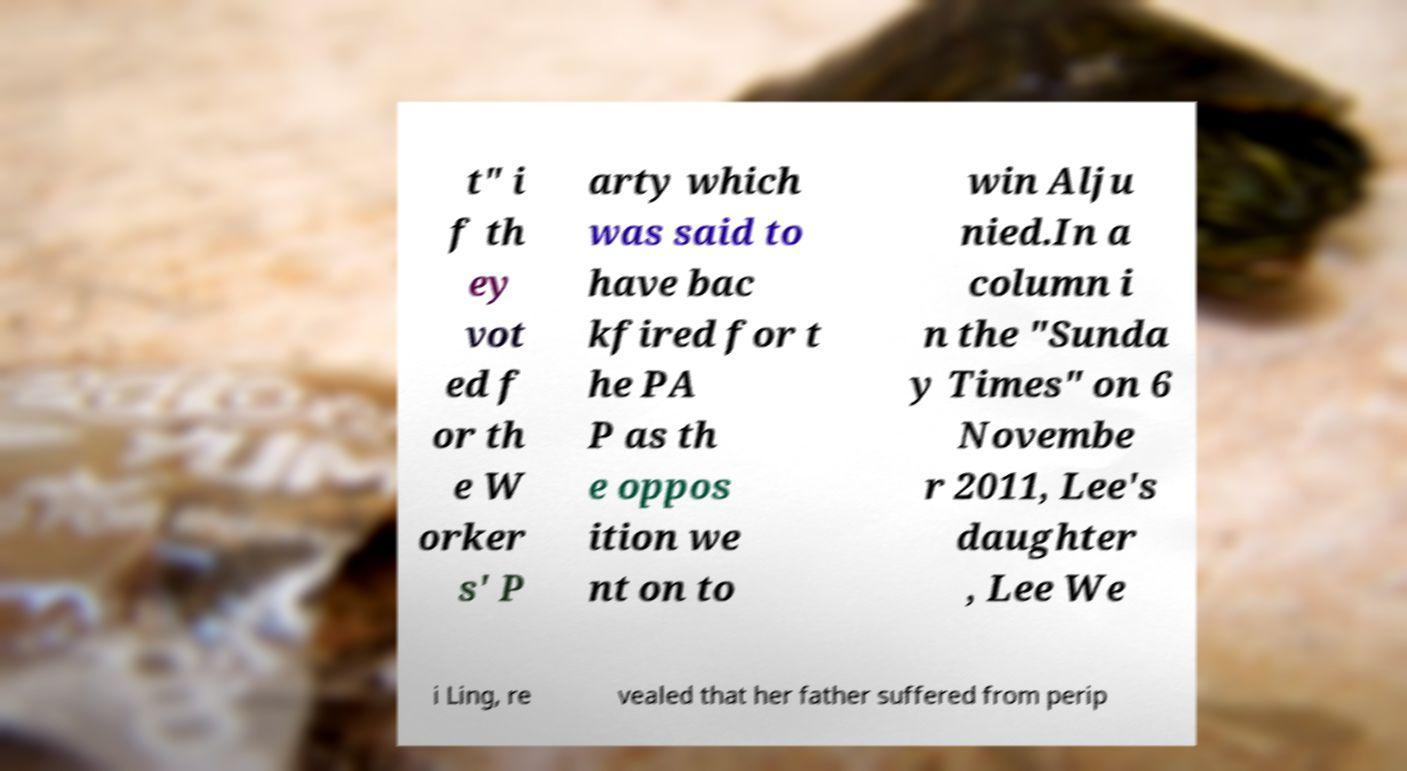Can you read and provide the text displayed in the image?This photo seems to have some interesting text. Can you extract and type it out for me? t" i f th ey vot ed f or th e W orker s' P arty which was said to have bac kfired for t he PA P as th e oppos ition we nt on to win Alju nied.In a column i n the "Sunda y Times" on 6 Novembe r 2011, Lee's daughter , Lee We i Ling, re vealed that her father suffered from perip 